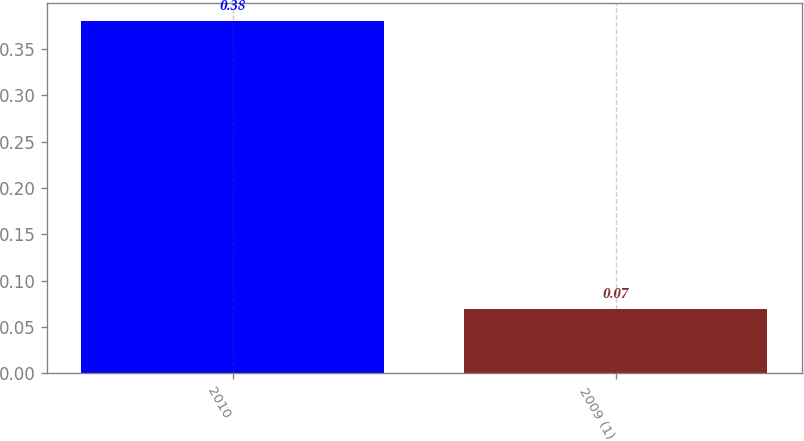Convert chart to OTSL. <chart><loc_0><loc_0><loc_500><loc_500><bar_chart><fcel>2010<fcel>2009 (1)<nl><fcel>0.38<fcel>0.07<nl></chart> 